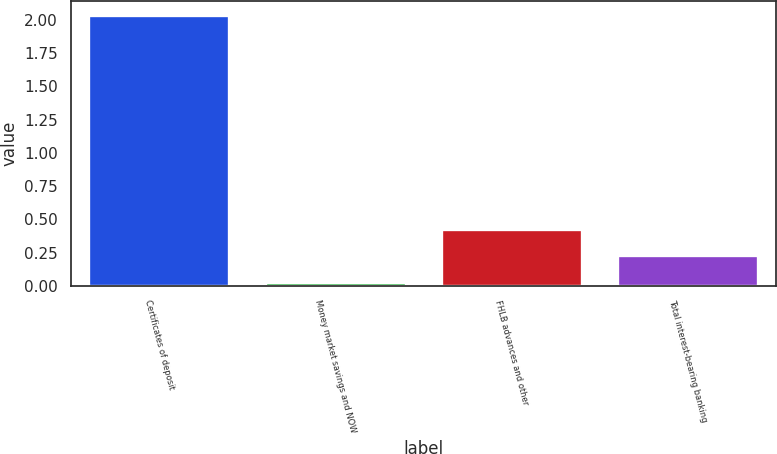Convert chart to OTSL. <chart><loc_0><loc_0><loc_500><loc_500><bar_chart><fcel>Certificates of deposit<fcel>Money market savings and NOW<fcel>FHLB advances and other<fcel>Total interest-bearing banking<nl><fcel>2.04<fcel>0.03<fcel>0.43<fcel>0.23<nl></chart> 